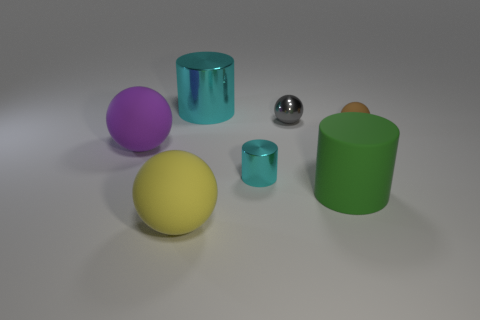Add 3 large cyan metal objects. How many objects exist? 10 Subtract all balls. How many objects are left? 3 Add 4 tiny gray shiny objects. How many tiny gray shiny objects are left? 5 Add 1 small purple cylinders. How many small purple cylinders exist? 1 Subtract 0 green balls. How many objects are left? 7 Subtract all brown spheres. Subtract all large yellow objects. How many objects are left? 5 